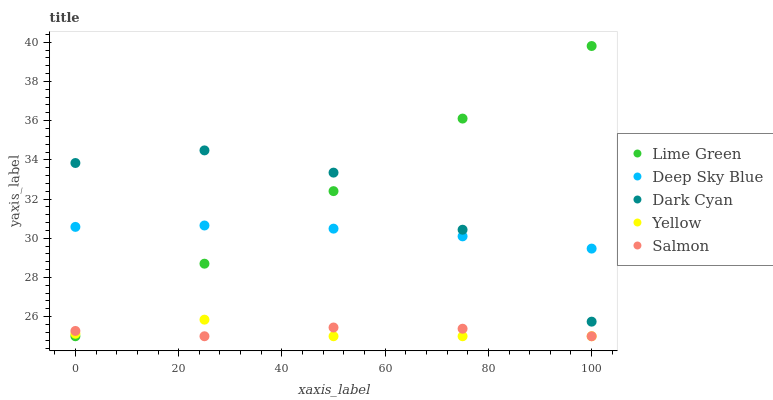Does Yellow have the minimum area under the curve?
Answer yes or no. Yes. Does Lime Green have the maximum area under the curve?
Answer yes or no. Yes. Does Salmon have the minimum area under the curve?
Answer yes or no. No. Does Salmon have the maximum area under the curve?
Answer yes or no. No. Is Lime Green the smoothest?
Answer yes or no. Yes. Is Dark Cyan the roughest?
Answer yes or no. Yes. Is Salmon the smoothest?
Answer yes or no. No. Is Salmon the roughest?
Answer yes or no. No. Does Salmon have the lowest value?
Answer yes or no. Yes. Does Deep Sky Blue have the lowest value?
Answer yes or no. No. Does Lime Green have the highest value?
Answer yes or no. Yes. Does Salmon have the highest value?
Answer yes or no. No. Is Yellow less than Deep Sky Blue?
Answer yes or no. Yes. Is Dark Cyan greater than Salmon?
Answer yes or no. Yes. Does Lime Green intersect Deep Sky Blue?
Answer yes or no. Yes. Is Lime Green less than Deep Sky Blue?
Answer yes or no. No. Is Lime Green greater than Deep Sky Blue?
Answer yes or no. No. Does Yellow intersect Deep Sky Blue?
Answer yes or no. No. 